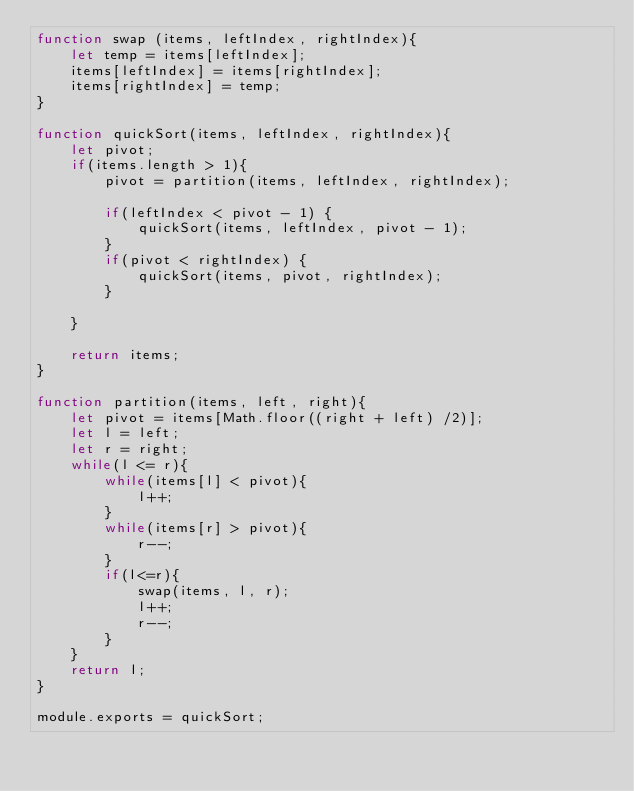Convert code to text. <code><loc_0><loc_0><loc_500><loc_500><_JavaScript_>function swap (items, leftIndex, rightIndex){
    let temp = items[leftIndex];
    items[leftIndex] = items[rightIndex];
    items[rightIndex] = temp;
}

function quickSort(items, leftIndex, rightIndex){
    let pivot;
    if(items.length > 1){
        pivot = partition(items, leftIndex, rightIndex);

        if(leftIndex < pivot - 1) {
            quickSort(items, leftIndex, pivot - 1);
        }
        if(pivot < rightIndex) {
            quickSort(items, pivot, rightIndex);
        }

    }

    return items;
}

function partition(items, left, right){
    let pivot = items[Math.floor((right + left) /2)];
    let l = left;
    let r = right;
    while(l <= r){
        while(items[l] < pivot){
            l++;
        }
        while(items[r] > pivot){
            r--;
        }
        if(l<=r){
            swap(items, l, r);
            l++;
            r--;
        }
    }
    return l;
}

module.exports = quickSort;
</code> 